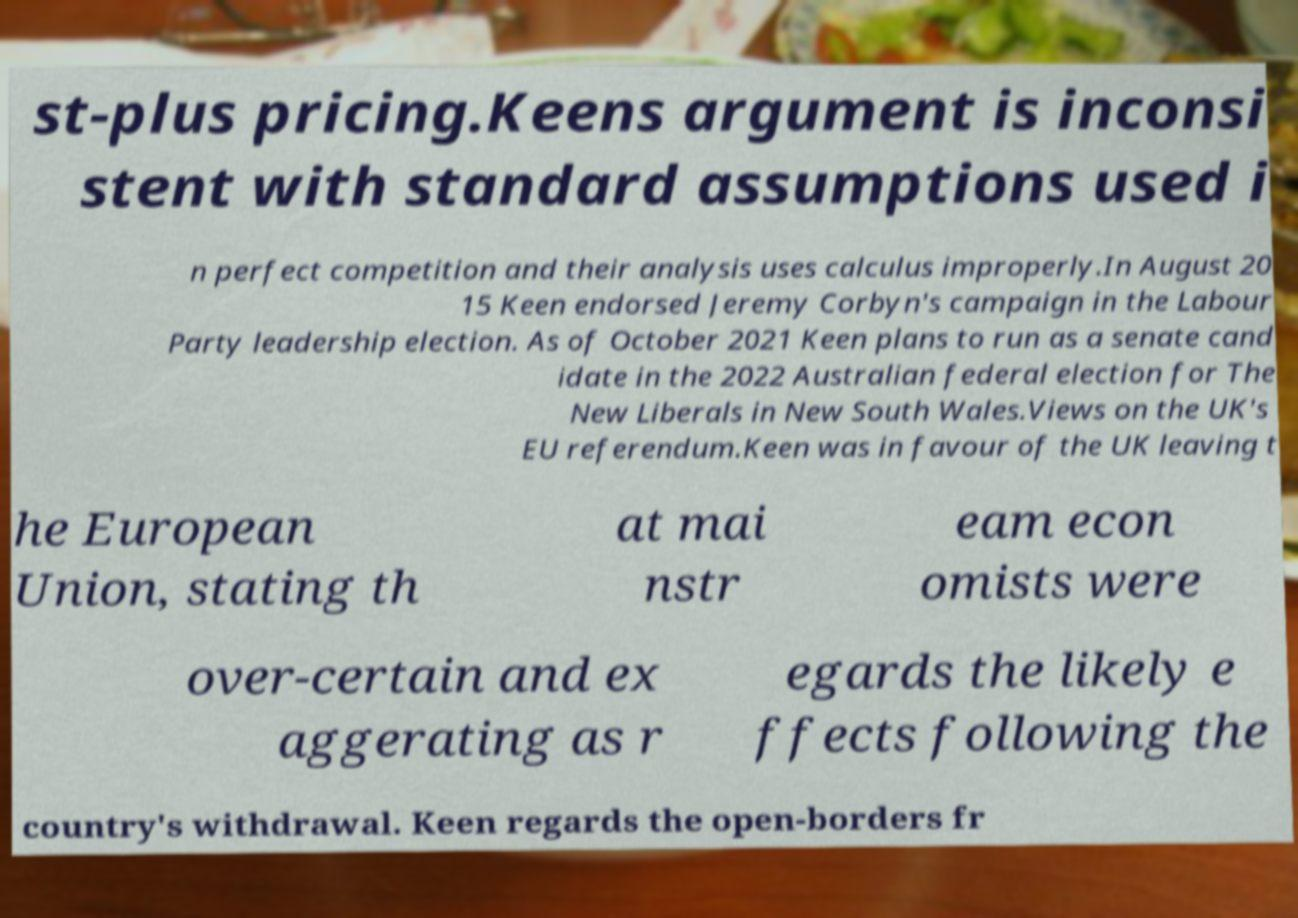What messages or text are displayed in this image? I need them in a readable, typed format. st-plus pricing.Keens argument is inconsi stent with standard assumptions used i n perfect competition and their analysis uses calculus improperly.In August 20 15 Keen endorsed Jeremy Corbyn's campaign in the Labour Party leadership election. As of October 2021 Keen plans to run as a senate cand idate in the 2022 Australian federal election for The New Liberals in New South Wales.Views on the UK's EU referendum.Keen was in favour of the UK leaving t he European Union, stating th at mai nstr eam econ omists were over-certain and ex aggerating as r egards the likely e ffects following the country's withdrawal. Keen regards the open-borders fr 